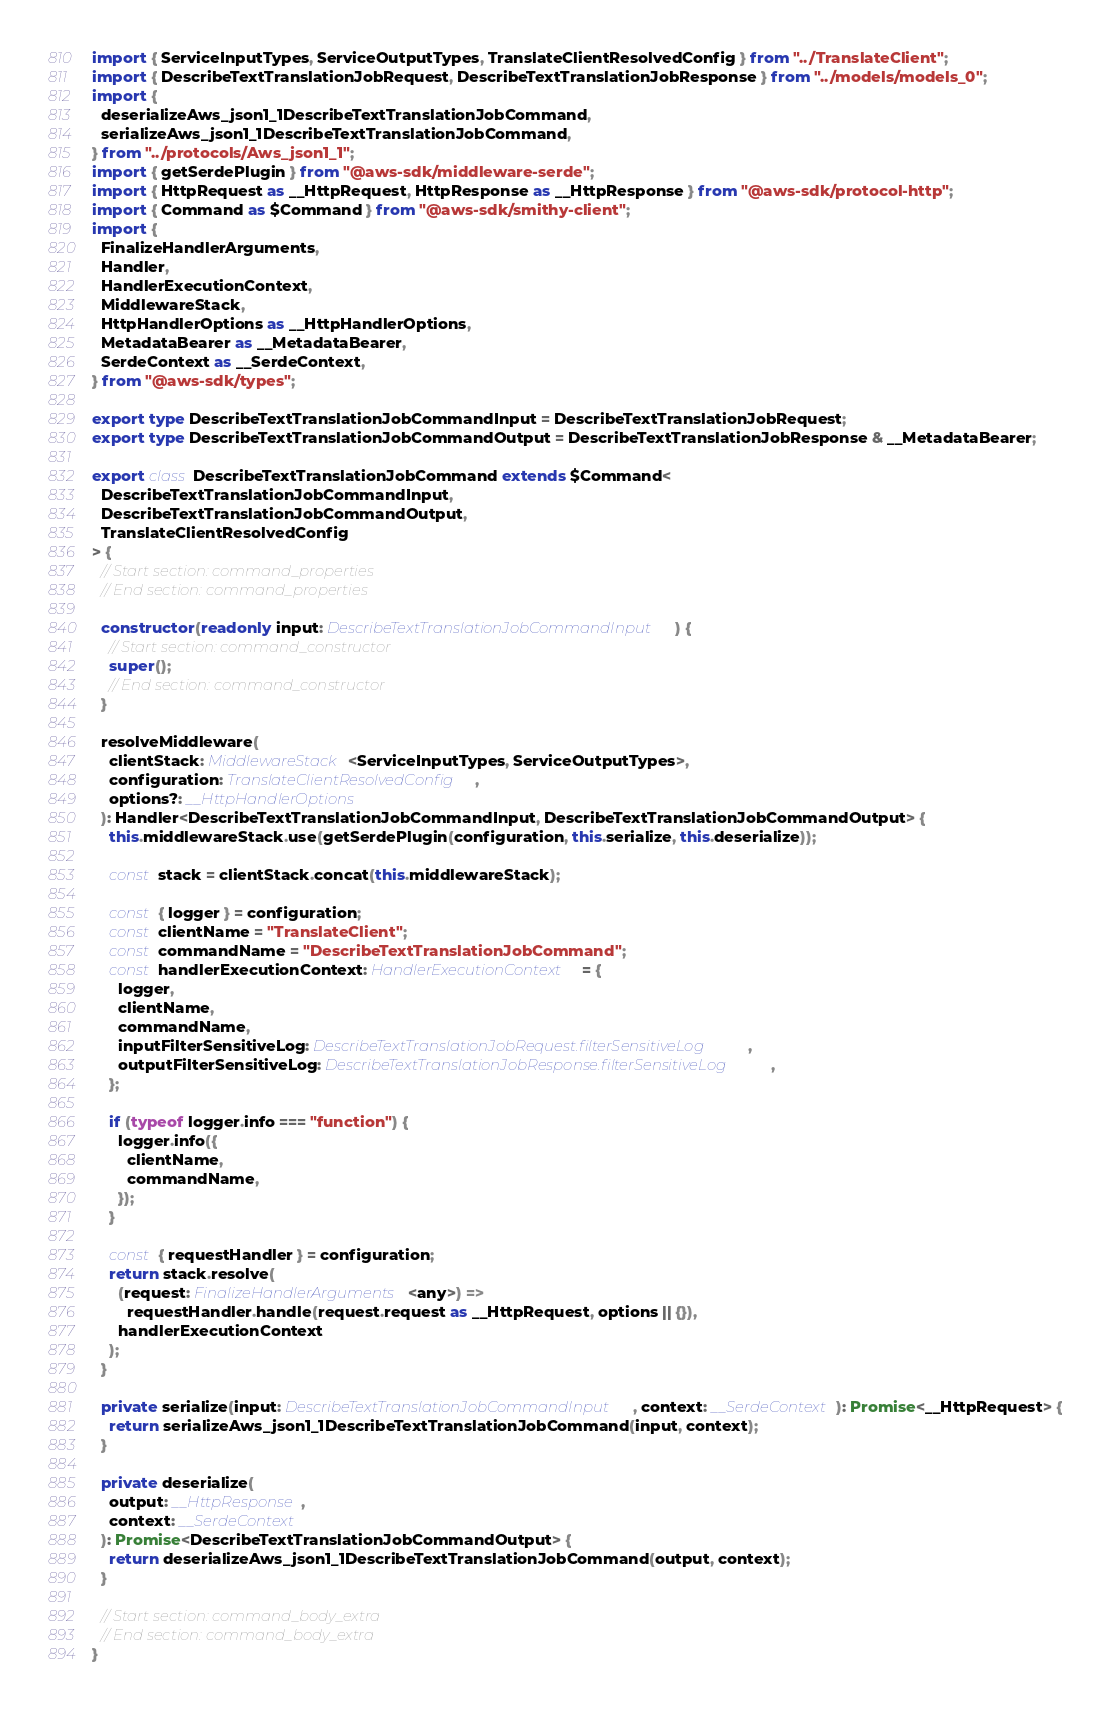Convert code to text. <code><loc_0><loc_0><loc_500><loc_500><_TypeScript_>import { ServiceInputTypes, ServiceOutputTypes, TranslateClientResolvedConfig } from "../TranslateClient";
import { DescribeTextTranslationJobRequest, DescribeTextTranslationJobResponse } from "../models/models_0";
import {
  deserializeAws_json1_1DescribeTextTranslationJobCommand,
  serializeAws_json1_1DescribeTextTranslationJobCommand,
} from "../protocols/Aws_json1_1";
import { getSerdePlugin } from "@aws-sdk/middleware-serde";
import { HttpRequest as __HttpRequest, HttpResponse as __HttpResponse } from "@aws-sdk/protocol-http";
import { Command as $Command } from "@aws-sdk/smithy-client";
import {
  FinalizeHandlerArguments,
  Handler,
  HandlerExecutionContext,
  MiddlewareStack,
  HttpHandlerOptions as __HttpHandlerOptions,
  MetadataBearer as __MetadataBearer,
  SerdeContext as __SerdeContext,
} from "@aws-sdk/types";

export type DescribeTextTranslationJobCommandInput = DescribeTextTranslationJobRequest;
export type DescribeTextTranslationJobCommandOutput = DescribeTextTranslationJobResponse & __MetadataBearer;

export class DescribeTextTranslationJobCommand extends $Command<
  DescribeTextTranslationJobCommandInput,
  DescribeTextTranslationJobCommandOutput,
  TranslateClientResolvedConfig
> {
  // Start section: command_properties
  // End section: command_properties

  constructor(readonly input: DescribeTextTranslationJobCommandInput) {
    // Start section: command_constructor
    super();
    // End section: command_constructor
  }

  resolveMiddleware(
    clientStack: MiddlewareStack<ServiceInputTypes, ServiceOutputTypes>,
    configuration: TranslateClientResolvedConfig,
    options?: __HttpHandlerOptions
  ): Handler<DescribeTextTranslationJobCommandInput, DescribeTextTranslationJobCommandOutput> {
    this.middlewareStack.use(getSerdePlugin(configuration, this.serialize, this.deserialize));

    const stack = clientStack.concat(this.middlewareStack);

    const { logger } = configuration;
    const clientName = "TranslateClient";
    const commandName = "DescribeTextTranslationJobCommand";
    const handlerExecutionContext: HandlerExecutionContext = {
      logger,
      clientName,
      commandName,
      inputFilterSensitiveLog: DescribeTextTranslationJobRequest.filterSensitiveLog,
      outputFilterSensitiveLog: DescribeTextTranslationJobResponse.filterSensitiveLog,
    };

    if (typeof logger.info === "function") {
      logger.info({
        clientName,
        commandName,
      });
    }

    const { requestHandler } = configuration;
    return stack.resolve(
      (request: FinalizeHandlerArguments<any>) =>
        requestHandler.handle(request.request as __HttpRequest, options || {}),
      handlerExecutionContext
    );
  }

  private serialize(input: DescribeTextTranslationJobCommandInput, context: __SerdeContext): Promise<__HttpRequest> {
    return serializeAws_json1_1DescribeTextTranslationJobCommand(input, context);
  }

  private deserialize(
    output: __HttpResponse,
    context: __SerdeContext
  ): Promise<DescribeTextTranslationJobCommandOutput> {
    return deserializeAws_json1_1DescribeTextTranslationJobCommand(output, context);
  }

  // Start section: command_body_extra
  // End section: command_body_extra
}
</code> 